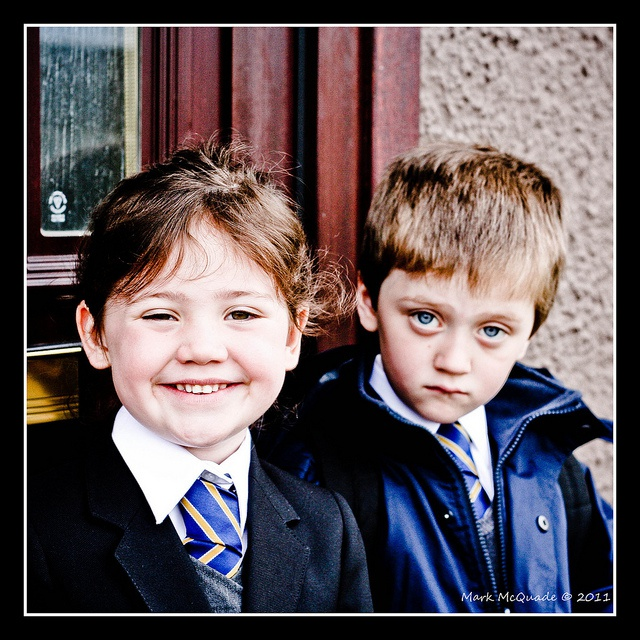Describe the objects in this image and their specific colors. I can see people in black, white, lightpink, and navy tones, people in black, lightgray, tan, and navy tones, tie in black, darkblue, white, and blue tones, and tie in black, lightgray, darkgray, and gray tones in this image. 